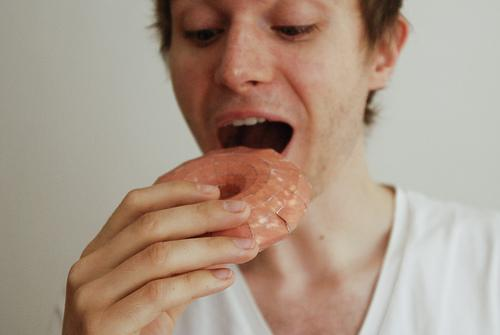What is the appearance of the donut's surface in the image? The donut has a pale glazed surface with a visible hole. What is the man's expression as he is about to eat the donut? The man's eyes are looking down at the donut, seemingly focused. Describe the orientation of the man's hand holding the donut. The man's hand is holding the donut with four fingers visible, all facing the same direction. Identify the subject in the image and what he is consuming. A man is eating a glazed donut with no bites taken out of it. What type of wall is behind the man in the image and what color is it? A white wall is behind the man. What body part of the man is about to interact with the food? The man's open mouth is about to take a bite of the donut. Mention a visible facial feature of the man in the image. One visible ear of the man. What color is the shirt the man is wearing in the image, and what type is it? The man is wearing a white V-neck t-shirt. Describe the man's hairstyle and color in the picture. The man has short, brown hair. Provide a count of the visible fingers on the man's hand in the image. Four fingers are visible on the man's hand. 